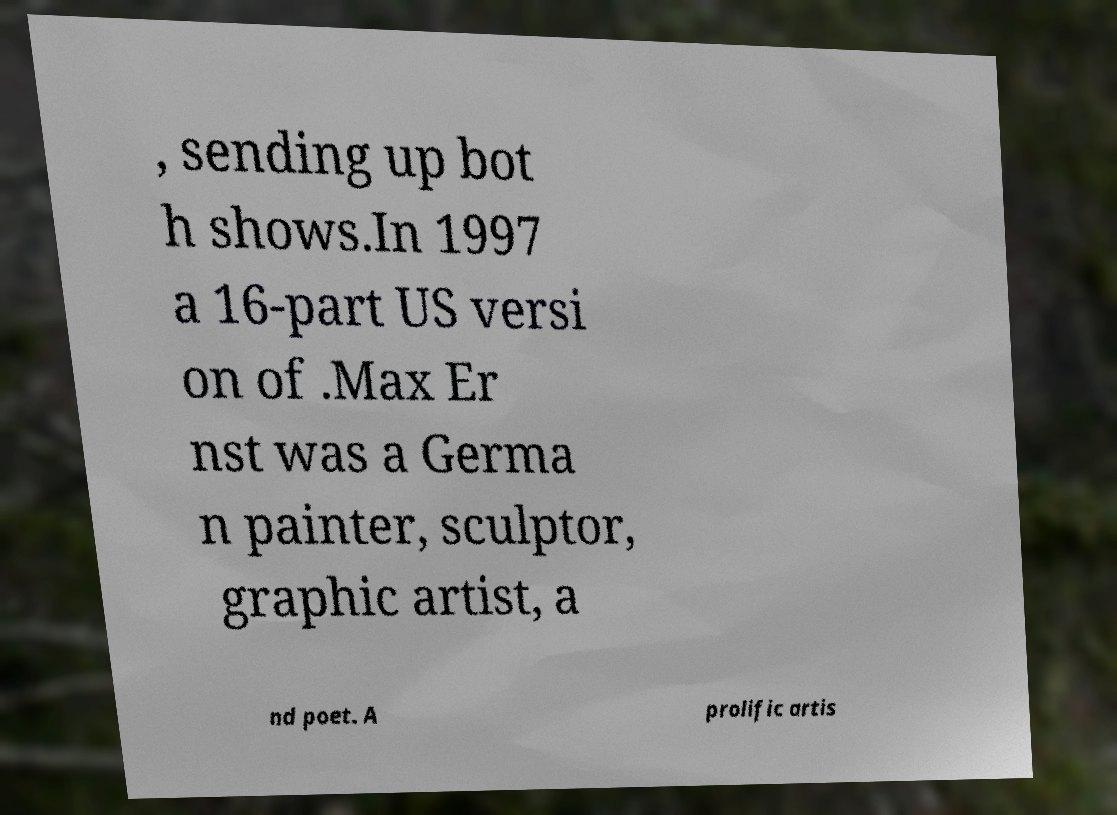Could you assist in decoding the text presented in this image and type it out clearly? , sending up bot h shows.In 1997 a 16-part US versi on of .Max Er nst was a Germa n painter, sculptor, graphic artist, a nd poet. A prolific artis 